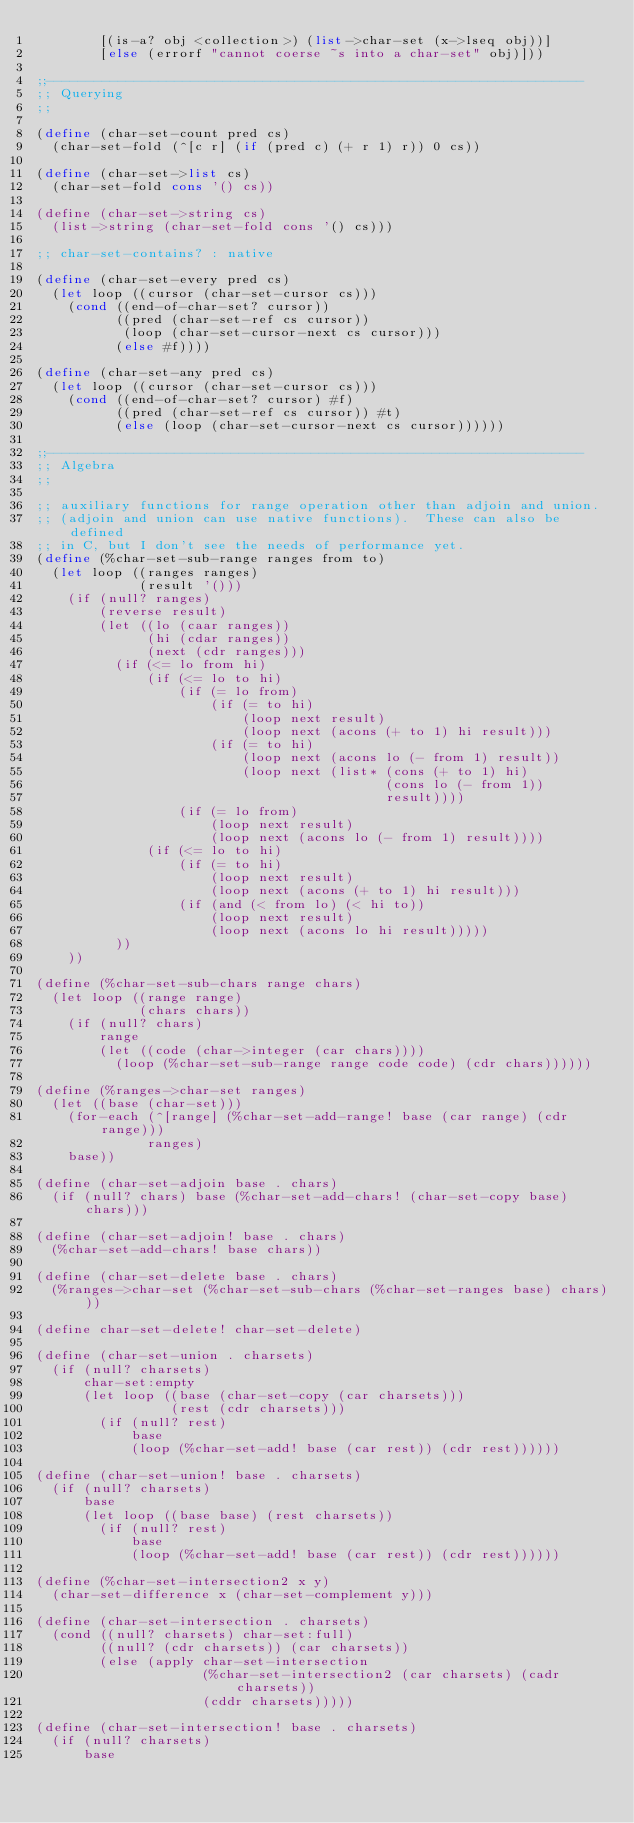<code> <loc_0><loc_0><loc_500><loc_500><_Scheme_>        [(is-a? obj <collection>) (list->char-set (x->lseq obj))]
        [else (errorf "cannot coerse ~s into a char-set" obj)]))

;;-------------------------------------------------------------------
;; Querying
;;

(define (char-set-count pred cs)
  (char-set-fold (^[c r] (if (pred c) (+ r 1) r)) 0 cs))

(define (char-set->list cs)
  (char-set-fold cons '() cs))

(define (char-set->string cs)
  (list->string (char-set-fold cons '() cs)))

;; char-set-contains? : native

(define (char-set-every pred cs)
  (let loop ((cursor (char-set-cursor cs)))
    (cond ((end-of-char-set? cursor))
          ((pred (char-set-ref cs cursor))
           (loop (char-set-cursor-next cs cursor)))
          (else #f))))

(define (char-set-any pred cs)
  (let loop ((cursor (char-set-cursor cs)))
    (cond ((end-of-char-set? cursor) #f)
          ((pred (char-set-ref cs cursor)) #t)
          (else (loop (char-set-cursor-next cs cursor))))))

;;-------------------------------------------------------------------
;; Algebra
;;

;; auxiliary functions for range operation other than adjoin and union.
;; (adjoin and union can use native functions).  These can also be defined
;; in C, but I don't see the needs of performance yet.
(define (%char-set-sub-range ranges from to)
  (let loop ((ranges ranges)
             (result '()))
    (if (null? ranges)
        (reverse result)
        (let ((lo (caar ranges))
              (hi (cdar ranges))
              (next (cdr ranges)))
          (if (<= lo from hi)
              (if (<= lo to hi)
                  (if (= lo from)
                      (if (= to hi)
                          (loop next result)
                          (loop next (acons (+ to 1) hi result)))
                      (if (= to hi)
                          (loop next (acons lo (- from 1) result))
                          (loop next (list* (cons (+ to 1) hi)
                                            (cons lo (- from 1))
                                            result))))
                  (if (= lo from)
                      (loop next result)
                      (loop next (acons lo (- from 1) result))))
              (if (<= lo to hi)
                  (if (= to hi)
                      (loop next result)
                      (loop next (acons (+ to 1) hi result)))
                  (if (and (< from lo) (< hi to))
                      (loop next result)
                      (loop next (acons lo hi result)))))
          ))
    ))

(define (%char-set-sub-chars range chars)
  (let loop ((range range)
             (chars chars))
    (if (null? chars)
        range
        (let ((code (char->integer (car chars))))
          (loop (%char-set-sub-range range code code) (cdr chars))))))

(define (%ranges->char-set ranges)
  (let ((base (char-set)))
    (for-each (^[range] (%char-set-add-range! base (car range) (cdr range)))
              ranges)
    base))

(define (char-set-adjoin base . chars)
  (if (null? chars) base (%char-set-add-chars! (char-set-copy base) chars)))

(define (char-set-adjoin! base . chars)
  (%char-set-add-chars! base chars))

(define (char-set-delete base . chars)
  (%ranges->char-set (%char-set-sub-chars (%char-set-ranges base) chars)))

(define char-set-delete! char-set-delete)

(define (char-set-union . charsets)
  (if (null? charsets)
      char-set:empty
      (let loop ((base (char-set-copy (car charsets)))
                 (rest (cdr charsets)))
        (if (null? rest)
            base
            (loop (%char-set-add! base (car rest)) (cdr rest))))))

(define (char-set-union! base . charsets)
  (if (null? charsets)
      base
      (let loop ((base base) (rest charsets))
        (if (null? rest)
            base
            (loop (%char-set-add! base (car rest)) (cdr rest))))))

(define (%char-set-intersection2 x y)
  (char-set-difference x (char-set-complement y)))

(define (char-set-intersection . charsets)
  (cond ((null? charsets) char-set:full)
        ((null? (cdr charsets)) (car charsets))
        (else (apply char-set-intersection
                     (%char-set-intersection2 (car charsets) (cadr charsets))
                     (cddr charsets)))))

(define (char-set-intersection! base . charsets)
  (if (null? charsets)
      base</code> 